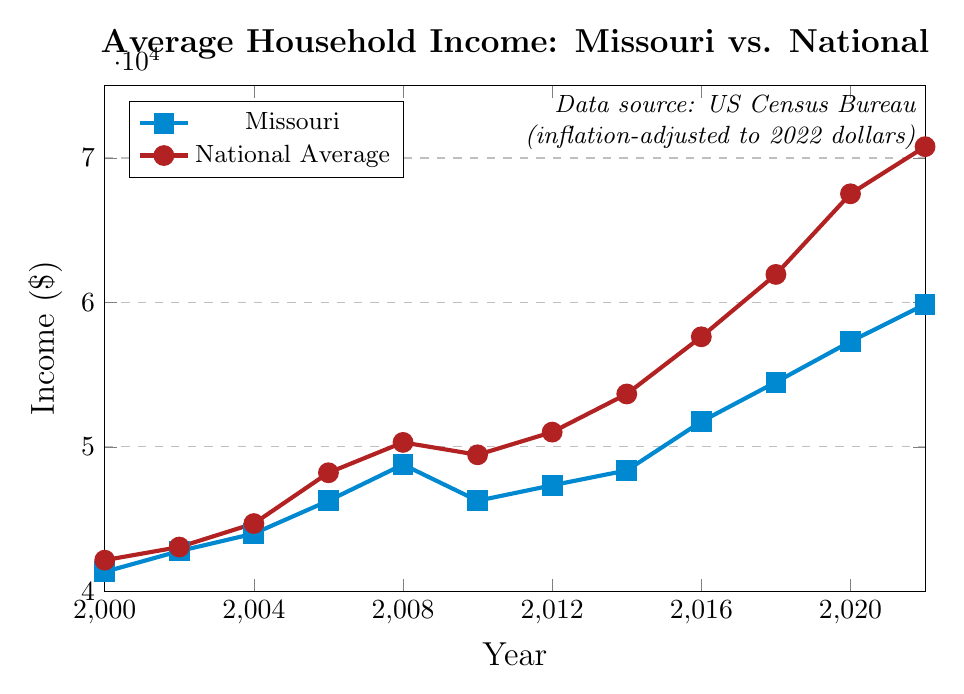What is the highest average household income for Missouri over the years shown? The highest average household income for Missouri can be found by looking at the highest point on the line representing Missouri in the chart. The highest value is at 2022 with an income of $59,859.
Answer: $59,859 How much higher was the US National Average income compared to Missouri in 2022? To find this, subtract Missouri's average household income in 2022 ($59,859) from the US National Average income in 2022 ($70,784). The difference is $70,784 - $59,859 = $10,925.
Answer: $10,925 In which year did Missouri's average household income remain the same as a previous year? Look for a flat segment in the Missouri income line, which happens between 2006 and 2010, showing Missouri’s income remained the same at $46,262.
Answer: 2010 What was the percentage increase in Missouri's average household income from 2000 to 2022? The percentage increase can be calculated using the formula: [(59859 - 41339) / 41339] * 100. First, calculate the difference: $59,859 - $41,339 = $18,520. Then divide by the 2000 value and multiply by 100: ($18,520 / $41,339) * 100 ≈ 44.8%.
Answer: 44.8% Which year saw the largest gap between Missouri's average household income and the US National Average? Examine the differences between the two lines for each year and identify the year with the greatest gap. In 2022, the gap was $10,925, which is largest compared to other years.
Answer: 2022 Between which consecutive years did Missouri experience the largest increase in average household income? Look at each year’s difference visually and compare. From the plot, the largest increase occurred between 2014 and 2016 with an increase of $51,746 - $48,363 = $3,383.
Answer: Between 2014 and 2016 By how much did the US National Average household income grow from 2000 to 2022? To find the growth, subtract the US National Average income in 2000 from that in 2022. So, $70,784 - $42,148 = $28,636.
Answer: $28,636 During which year(s) did both Missouri and National Average incomes decrease compared to the previous year? Examine the trends for both lines for a decrease. Both lines show a decline from 2008 to 2010.
Answer: 2010 What is the average of Missouri's income values for the years shown? Sum all the Missouri values then divide by the number of years. 
(41,339 + 42,776 + 43,988 + 46,262 + 48,769 + 46,262 + 47,333 + 48,363 + 51,746 + 54,478 + 57,290 + 59,859) / 12 ≈ 49,910.25
Answer: $49,910.25 Which color represents the Missouri income trend on the plot? Observe the color of the line representing Missouri. The Missouri income trend is represented by a blue line.
Answer: Blue 